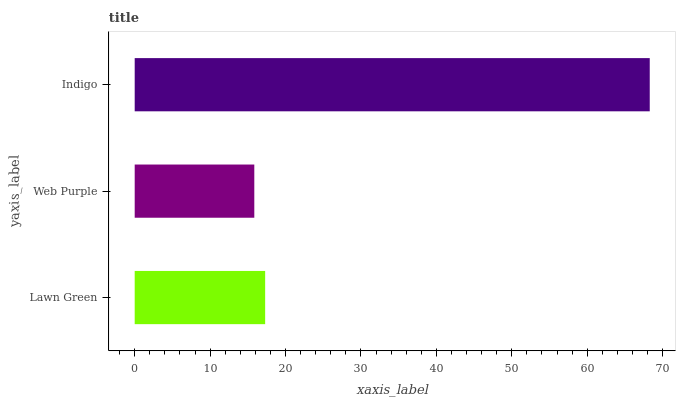Is Web Purple the minimum?
Answer yes or no. Yes. Is Indigo the maximum?
Answer yes or no. Yes. Is Indigo the minimum?
Answer yes or no. No. Is Web Purple the maximum?
Answer yes or no. No. Is Indigo greater than Web Purple?
Answer yes or no. Yes. Is Web Purple less than Indigo?
Answer yes or no. Yes. Is Web Purple greater than Indigo?
Answer yes or no. No. Is Indigo less than Web Purple?
Answer yes or no. No. Is Lawn Green the high median?
Answer yes or no. Yes. Is Lawn Green the low median?
Answer yes or no. Yes. Is Indigo the high median?
Answer yes or no. No. Is Web Purple the low median?
Answer yes or no. No. 